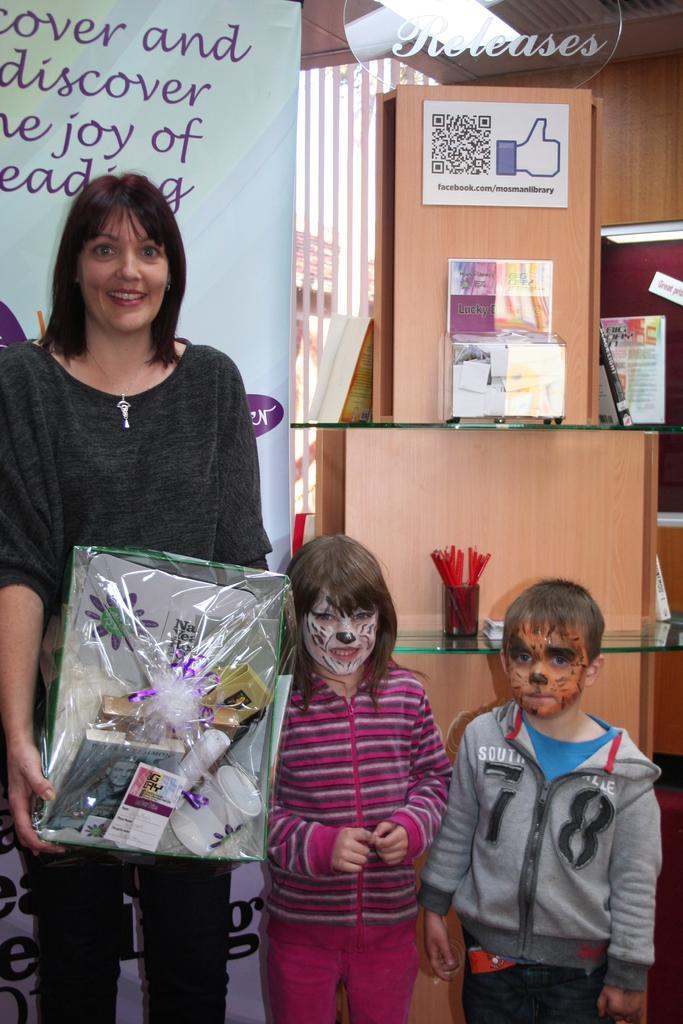How would you summarize this image in a sentence or two? In This image there is one woman standing and she is holding one box, and beside the women there are two boys standing. And in the background there are some shelves, and in that shelves there are some objects and some posters are stick to the wall. And on the left side there is one board, on the board there is text. 